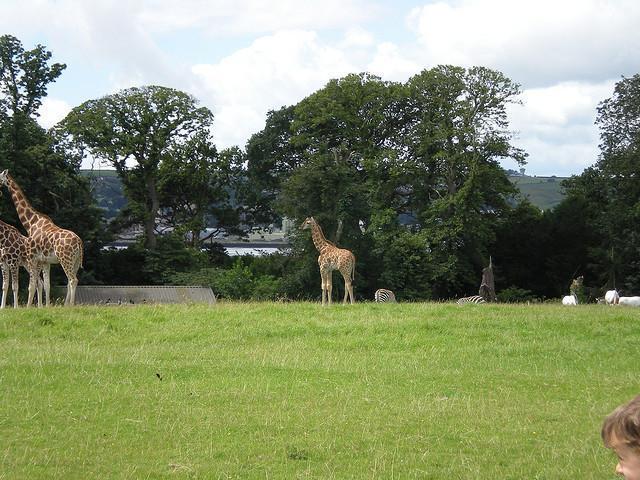How many species of animals do you see?
Give a very brief answer. 2. How many horses are there?
Give a very brief answer. 0. How many giraffes can you see?
Give a very brief answer. 2. How many cat tails are visible in the image?
Give a very brief answer. 0. 